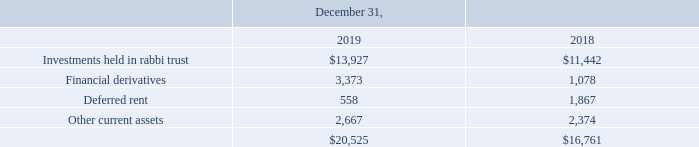Note 11. Other Current Assets
Other current assets consisted of the following (in thousands):
What was the amount of deferred rent in 2019?
Answer scale should be: thousand. 558. What was the amount of Other current assets in 2018?
Answer scale should be: thousand. 2,374. What are the components under other current assets in the table? Investments held in rabbi trust, financial derivatives, deferred rent, other current assets. In which year was the amount of Other current assets larger? 2,667>2,374
Answer: 2019. What was the change in total other current assets in 2019 from 2018?
Answer scale should be: thousand. 20,525-16,761
Answer: 3764. What was the percentage change in total other current assets in 2019 from 2018?
Answer scale should be: percent. (20,525-16,761)/16,761
Answer: 22.46. 